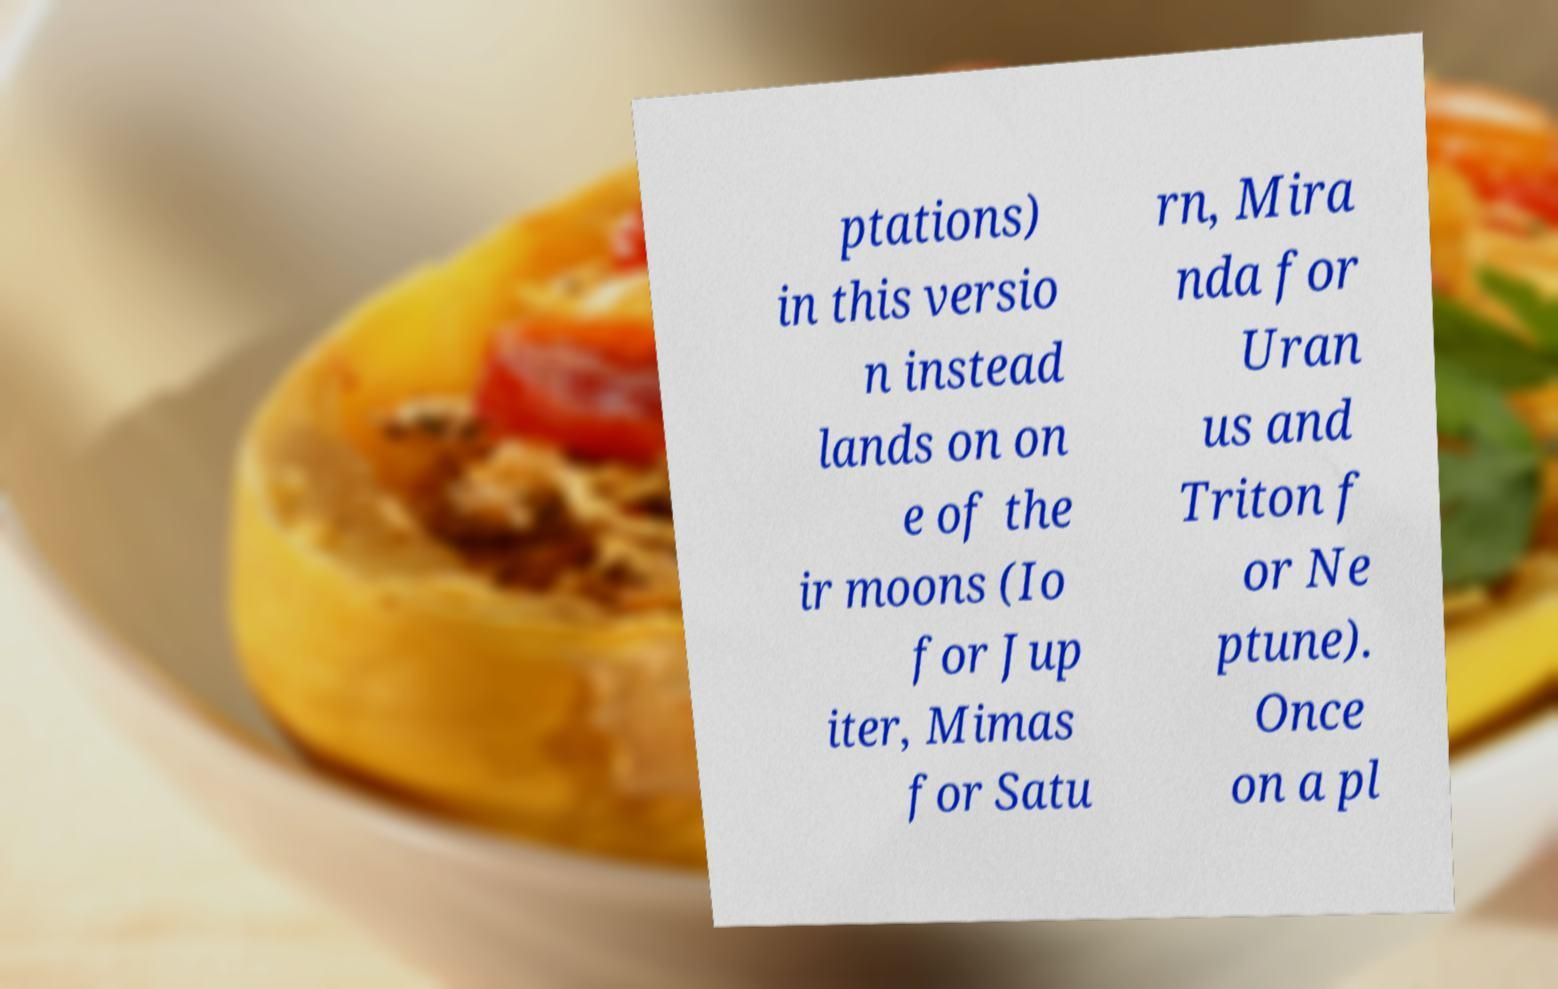Can you read and provide the text displayed in the image?This photo seems to have some interesting text. Can you extract and type it out for me? ptations) in this versio n instead lands on on e of the ir moons (Io for Jup iter, Mimas for Satu rn, Mira nda for Uran us and Triton f or Ne ptune). Once on a pl 